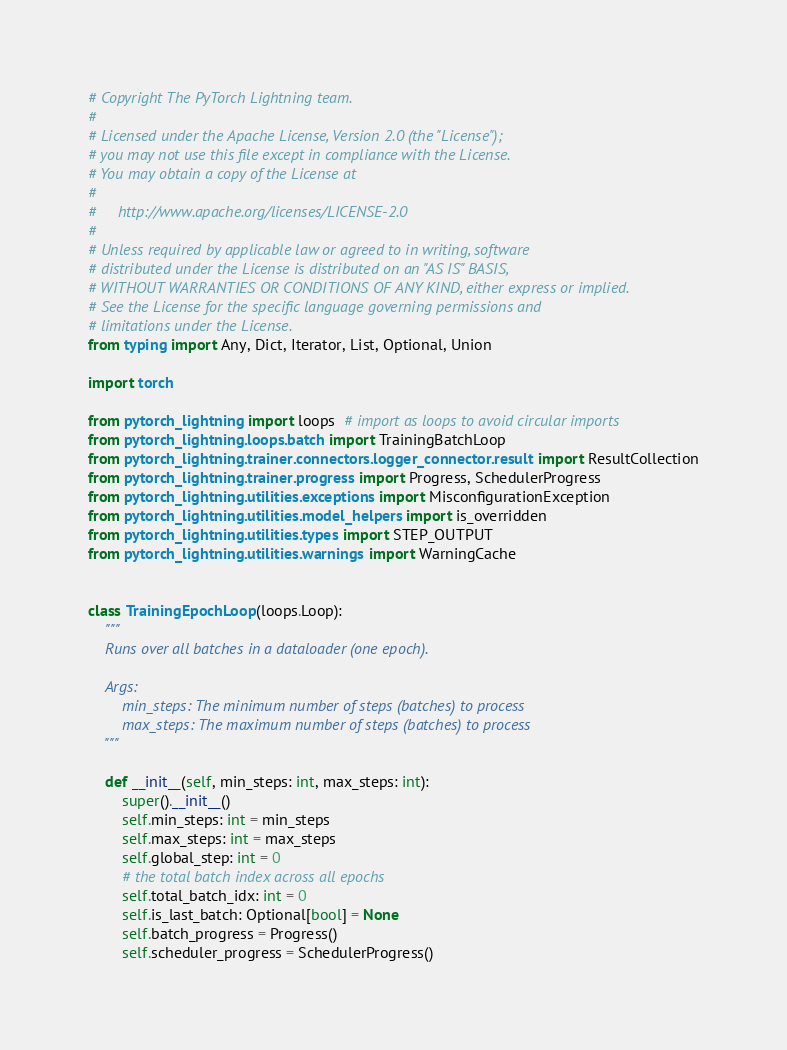<code> <loc_0><loc_0><loc_500><loc_500><_Python_># Copyright The PyTorch Lightning team.
#
# Licensed under the Apache License, Version 2.0 (the "License");
# you may not use this file except in compliance with the License.
# You may obtain a copy of the License at
#
#     http://www.apache.org/licenses/LICENSE-2.0
#
# Unless required by applicable law or agreed to in writing, software
# distributed under the License is distributed on an "AS IS" BASIS,
# WITHOUT WARRANTIES OR CONDITIONS OF ANY KIND, either express or implied.
# See the License for the specific language governing permissions and
# limitations under the License.
from typing import Any, Dict, Iterator, List, Optional, Union

import torch

from pytorch_lightning import loops  # import as loops to avoid circular imports
from pytorch_lightning.loops.batch import TrainingBatchLoop
from pytorch_lightning.trainer.connectors.logger_connector.result import ResultCollection
from pytorch_lightning.trainer.progress import Progress, SchedulerProgress
from pytorch_lightning.utilities.exceptions import MisconfigurationException
from pytorch_lightning.utilities.model_helpers import is_overridden
from pytorch_lightning.utilities.types import STEP_OUTPUT
from pytorch_lightning.utilities.warnings import WarningCache


class TrainingEpochLoop(loops.Loop):
    """
    Runs over all batches in a dataloader (one epoch).

    Args:
        min_steps: The minimum number of steps (batches) to process
        max_steps: The maximum number of steps (batches) to process
    """

    def __init__(self, min_steps: int, max_steps: int):
        super().__init__()
        self.min_steps: int = min_steps
        self.max_steps: int = max_steps
        self.global_step: int = 0
        # the total batch index across all epochs
        self.total_batch_idx: int = 0
        self.is_last_batch: Optional[bool] = None
        self.batch_progress = Progress()
        self.scheduler_progress = SchedulerProgress()
</code> 